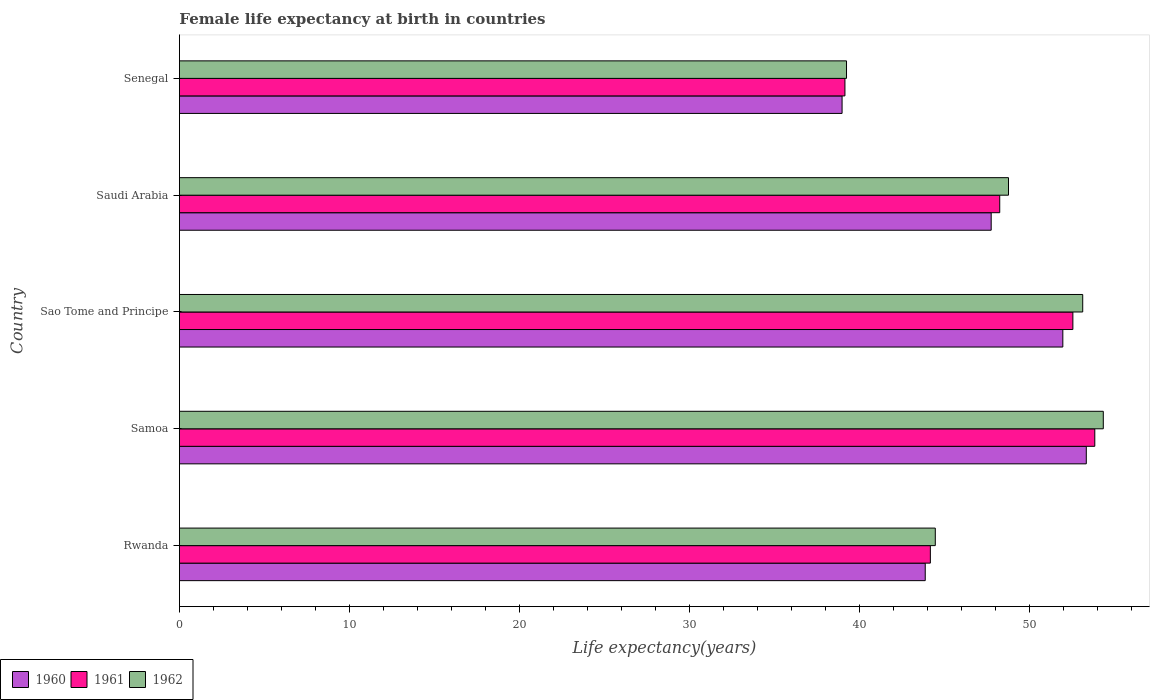How many different coloured bars are there?
Give a very brief answer. 3. Are the number of bars per tick equal to the number of legend labels?
Give a very brief answer. Yes. Are the number of bars on each tick of the Y-axis equal?
Provide a short and direct response. Yes. How many bars are there on the 1st tick from the top?
Provide a succinct answer. 3. How many bars are there on the 5th tick from the bottom?
Your answer should be compact. 3. What is the label of the 5th group of bars from the top?
Keep it short and to the point. Rwanda. What is the female life expectancy at birth in 1962 in Rwanda?
Make the answer very short. 44.47. Across all countries, what is the maximum female life expectancy at birth in 1960?
Your answer should be very brief. 53.35. Across all countries, what is the minimum female life expectancy at birth in 1960?
Your answer should be very brief. 38.98. In which country was the female life expectancy at birth in 1962 maximum?
Make the answer very short. Samoa. In which country was the female life expectancy at birth in 1961 minimum?
Offer a terse response. Senegal. What is the total female life expectancy at birth in 1962 in the graph?
Your answer should be very brief. 239.97. What is the difference between the female life expectancy at birth in 1962 in Samoa and that in Senegal?
Offer a terse response. 15.11. What is the difference between the female life expectancy at birth in 1962 in Senegal and the female life expectancy at birth in 1961 in Sao Tome and Principe?
Provide a short and direct response. -13.32. What is the average female life expectancy at birth in 1961 per country?
Keep it short and to the point. 47.6. What is the difference between the female life expectancy at birth in 1961 and female life expectancy at birth in 1962 in Rwanda?
Give a very brief answer. -0.29. In how many countries, is the female life expectancy at birth in 1961 greater than 52 years?
Ensure brevity in your answer.  2. What is the ratio of the female life expectancy at birth in 1961 in Rwanda to that in Samoa?
Give a very brief answer. 0.82. Is the female life expectancy at birth in 1961 in Saudi Arabia less than that in Senegal?
Make the answer very short. No. Is the difference between the female life expectancy at birth in 1961 in Rwanda and Senegal greater than the difference between the female life expectancy at birth in 1962 in Rwanda and Senegal?
Provide a short and direct response. No. What is the difference between the highest and the second highest female life expectancy at birth in 1962?
Give a very brief answer. 1.21. What is the difference between the highest and the lowest female life expectancy at birth in 1961?
Your answer should be compact. 14.7. In how many countries, is the female life expectancy at birth in 1960 greater than the average female life expectancy at birth in 1960 taken over all countries?
Give a very brief answer. 3. What does the 2nd bar from the bottom in Samoa represents?
Give a very brief answer. 1961. Is it the case that in every country, the sum of the female life expectancy at birth in 1962 and female life expectancy at birth in 1961 is greater than the female life expectancy at birth in 1960?
Your answer should be compact. Yes. How many bars are there?
Give a very brief answer. 15. How many countries are there in the graph?
Ensure brevity in your answer.  5. What is the difference between two consecutive major ticks on the X-axis?
Your answer should be compact. 10. Are the values on the major ticks of X-axis written in scientific E-notation?
Make the answer very short. No. Where does the legend appear in the graph?
Ensure brevity in your answer.  Bottom left. How many legend labels are there?
Your response must be concise. 3. How are the legend labels stacked?
Your response must be concise. Horizontal. What is the title of the graph?
Provide a short and direct response. Female life expectancy at birth in countries. What is the label or title of the X-axis?
Give a very brief answer. Life expectancy(years). What is the Life expectancy(years) in 1960 in Rwanda?
Give a very brief answer. 43.88. What is the Life expectancy(years) of 1961 in Rwanda?
Offer a very short reply. 44.18. What is the Life expectancy(years) in 1962 in Rwanda?
Ensure brevity in your answer.  44.47. What is the Life expectancy(years) in 1960 in Samoa?
Your answer should be compact. 53.35. What is the Life expectancy(years) of 1961 in Samoa?
Your response must be concise. 53.85. What is the Life expectancy(years) in 1962 in Samoa?
Your answer should be compact. 54.35. What is the Life expectancy(years) in 1960 in Sao Tome and Principe?
Offer a very short reply. 51.97. What is the Life expectancy(years) in 1961 in Sao Tome and Principe?
Provide a succinct answer. 52.56. What is the Life expectancy(years) of 1962 in Sao Tome and Principe?
Keep it short and to the point. 53.14. What is the Life expectancy(years) of 1960 in Saudi Arabia?
Make the answer very short. 47.76. What is the Life expectancy(years) in 1961 in Saudi Arabia?
Your response must be concise. 48.26. What is the Life expectancy(years) in 1962 in Saudi Arabia?
Offer a very short reply. 48.77. What is the Life expectancy(years) of 1960 in Senegal?
Provide a succinct answer. 38.98. What is the Life expectancy(years) in 1961 in Senegal?
Provide a short and direct response. 39.15. What is the Life expectancy(years) in 1962 in Senegal?
Offer a terse response. 39.24. Across all countries, what is the maximum Life expectancy(years) of 1960?
Give a very brief answer. 53.35. Across all countries, what is the maximum Life expectancy(years) in 1961?
Provide a short and direct response. 53.85. Across all countries, what is the maximum Life expectancy(years) of 1962?
Provide a short and direct response. 54.35. Across all countries, what is the minimum Life expectancy(years) of 1960?
Ensure brevity in your answer.  38.98. Across all countries, what is the minimum Life expectancy(years) in 1961?
Ensure brevity in your answer.  39.15. Across all countries, what is the minimum Life expectancy(years) in 1962?
Your response must be concise. 39.24. What is the total Life expectancy(years) of 1960 in the graph?
Give a very brief answer. 235.93. What is the total Life expectancy(years) of 1961 in the graph?
Your response must be concise. 238. What is the total Life expectancy(years) in 1962 in the graph?
Provide a short and direct response. 239.97. What is the difference between the Life expectancy(years) in 1960 in Rwanda and that in Samoa?
Provide a short and direct response. -9.47. What is the difference between the Life expectancy(years) of 1961 in Rwanda and that in Samoa?
Your answer should be compact. -9.67. What is the difference between the Life expectancy(years) of 1962 in Rwanda and that in Samoa?
Provide a short and direct response. -9.88. What is the difference between the Life expectancy(years) in 1960 in Rwanda and that in Sao Tome and Principe?
Offer a very short reply. -8.09. What is the difference between the Life expectancy(years) of 1961 in Rwanda and that in Sao Tome and Principe?
Your response must be concise. -8.38. What is the difference between the Life expectancy(years) in 1962 in Rwanda and that in Sao Tome and Principe?
Your response must be concise. -8.67. What is the difference between the Life expectancy(years) in 1960 in Rwanda and that in Saudi Arabia?
Provide a short and direct response. -3.88. What is the difference between the Life expectancy(years) in 1961 in Rwanda and that in Saudi Arabia?
Offer a terse response. -4.08. What is the difference between the Life expectancy(years) of 1962 in Rwanda and that in Saudi Arabia?
Keep it short and to the point. -4.31. What is the difference between the Life expectancy(years) of 1960 in Rwanda and that in Senegal?
Ensure brevity in your answer.  4.89. What is the difference between the Life expectancy(years) in 1961 in Rwanda and that in Senegal?
Provide a short and direct response. 5.03. What is the difference between the Life expectancy(years) of 1962 in Rwanda and that in Senegal?
Make the answer very short. 5.22. What is the difference between the Life expectancy(years) in 1960 in Samoa and that in Sao Tome and Principe?
Provide a succinct answer. 1.38. What is the difference between the Life expectancy(years) in 1961 in Samoa and that in Sao Tome and Principe?
Ensure brevity in your answer.  1.29. What is the difference between the Life expectancy(years) in 1962 in Samoa and that in Sao Tome and Principe?
Your answer should be very brief. 1.21. What is the difference between the Life expectancy(years) in 1960 in Samoa and that in Saudi Arabia?
Keep it short and to the point. 5.59. What is the difference between the Life expectancy(years) of 1961 in Samoa and that in Saudi Arabia?
Offer a very short reply. 5.59. What is the difference between the Life expectancy(years) in 1962 in Samoa and that in Saudi Arabia?
Your response must be concise. 5.58. What is the difference between the Life expectancy(years) of 1960 in Samoa and that in Senegal?
Provide a succinct answer. 14.37. What is the difference between the Life expectancy(years) in 1961 in Samoa and that in Senegal?
Your answer should be very brief. 14.7. What is the difference between the Life expectancy(years) in 1962 in Samoa and that in Senegal?
Provide a short and direct response. 15.11. What is the difference between the Life expectancy(years) of 1960 in Sao Tome and Principe and that in Saudi Arabia?
Offer a very short reply. 4.21. What is the difference between the Life expectancy(years) in 1961 in Sao Tome and Principe and that in Saudi Arabia?
Your answer should be very brief. 4.3. What is the difference between the Life expectancy(years) in 1962 in Sao Tome and Principe and that in Saudi Arabia?
Make the answer very short. 4.37. What is the difference between the Life expectancy(years) in 1960 in Sao Tome and Principe and that in Senegal?
Offer a terse response. 12.99. What is the difference between the Life expectancy(years) in 1961 in Sao Tome and Principe and that in Senegal?
Give a very brief answer. 13.41. What is the difference between the Life expectancy(years) of 1962 in Sao Tome and Principe and that in Senegal?
Your response must be concise. 13.89. What is the difference between the Life expectancy(years) of 1960 in Saudi Arabia and that in Senegal?
Give a very brief answer. 8.77. What is the difference between the Life expectancy(years) of 1961 in Saudi Arabia and that in Senegal?
Provide a short and direct response. 9.11. What is the difference between the Life expectancy(years) in 1962 in Saudi Arabia and that in Senegal?
Your answer should be compact. 9.53. What is the difference between the Life expectancy(years) of 1960 in Rwanda and the Life expectancy(years) of 1961 in Samoa?
Your answer should be very brief. -9.97. What is the difference between the Life expectancy(years) of 1960 in Rwanda and the Life expectancy(years) of 1962 in Samoa?
Offer a terse response. -10.47. What is the difference between the Life expectancy(years) of 1961 in Rwanda and the Life expectancy(years) of 1962 in Samoa?
Offer a terse response. -10.17. What is the difference between the Life expectancy(years) of 1960 in Rwanda and the Life expectancy(years) of 1961 in Sao Tome and Principe?
Ensure brevity in your answer.  -8.69. What is the difference between the Life expectancy(years) in 1960 in Rwanda and the Life expectancy(years) in 1962 in Sao Tome and Principe?
Keep it short and to the point. -9.26. What is the difference between the Life expectancy(years) in 1961 in Rwanda and the Life expectancy(years) in 1962 in Sao Tome and Principe?
Your answer should be compact. -8.96. What is the difference between the Life expectancy(years) of 1960 in Rwanda and the Life expectancy(years) of 1961 in Saudi Arabia?
Provide a short and direct response. -4.38. What is the difference between the Life expectancy(years) in 1960 in Rwanda and the Life expectancy(years) in 1962 in Saudi Arabia?
Your answer should be very brief. -4.9. What is the difference between the Life expectancy(years) of 1961 in Rwanda and the Life expectancy(years) of 1962 in Saudi Arabia?
Provide a short and direct response. -4.6. What is the difference between the Life expectancy(years) in 1960 in Rwanda and the Life expectancy(years) in 1961 in Senegal?
Offer a very short reply. 4.72. What is the difference between the Life expectancy(years) in 1960 in Rwanda and the Life expectancy(years) in 1962 in Senegal?
Your answer should be very brief. 4.63. What is the difference between the Life expectancy(years) of 1961 in Rwanda and the Life expectancy(years) of 1962 in Senegal?
Offer a terse response. 4.93. What is the difference between the Life expectancy(years) of 1960 in Samoa and the Life expectancy(years) of 1961 in Sao Tome and Principe?
Provide a succinct answer. 0.79. What is the difference between the Life expectancy(years) of 1960 in Samoa and the Life expectancy(years) of 1962 in Sao Tome and Principe?
Your answer should be compact. 0.21. What is the difference between the Life expectancy(years) in 1961 in Samoa and the Life expectancy(years) in 1962 in Sao Tome and Principe?
Your response must be concise. 0.71. What is the difference between the Life expectancy(years) of 1960 in Samoa and the Life expectancy(years) of 1961 in Saudi Arabia?
Provide a short and direct response. 5.09. What is the difference between the Life expectancy(years) of 1960 in Samoa and the Life expectancy(years) of 1962 in Saudi Arabia?
Your response must be concise. 4.58. What is the difference between the Life expectancy(years) in 1961 in Samoa and the Life expectancy(years) in 1962 in Saudi Arabia?
Offer a very short reply. 5.08. What is the difference between the Life expectancy(years) in 1960 in Samoa and the Life expectancy(years) in 1961 in Senegal?
Provide a succinct answer. 14.2. What is the difference between the Life expectancy(years) of 1960 in Samoa and the Life expectancy(years) of 1962 in Senegal?
Offer a very short reply. 14.11. What is the difference between the Life expectancy(years) in 1961 in Samoa and the Life expectancy(years) in 1962 in Senegal?
Your answer should be very brief. 14.61. What is the difference between the Life expectancy(years) of 1960 in Sao Tome and Principe and the Life expectancy(years) of 1961 in Saudi Arabia?
Provide a succinct answer. 3.71. What is the difference between the Life expectancy(years) of 1960 in Sao Tome and Principe and the Life expectancy(years) of 1962 in Saudi Arabia?
Provide a short and direct response. 3.2. What is the difference between the Life expectancy(years) of 1961 in Sao Tome and Principe and the Life expectancy(years) of 1962 in Saudi Arabia?
Make the answer very short. 3.79. What is the difference between the Life expectancy(years) in 1960 in Sao Tome and Principe and the Life expectancy(years) in 1961 in Senegal?
Your answer should be compact. 12.82. What is the difference between the Life expectancy(years) in 1960 in Sao Tome and Principe and the Life expectancy(years) in 1962 in Senegal?
Make the answer very short. 12.72. What is the difference between the Life expectancy(years) in 1961 in Sao Tome and Principe and the Life expectancy(years) in 1962 in Senegal?
Keep it short and to the point. 13.32. What is the difference between the Life expectancy(years) in 1960 in Saudi Arabia and the Life expectancy(years) in 1961 in Senegal?
Your answer should be very brief. 8.6. What is the difference between the Life expectancy(years) in 1960 in Saudi Arabia and the Life expectancy(years) in 1962 in Senegal?
Make the answer very short. 8.51. What is the difference between the Life expectancy(years) of 1961 in Saudi Arabia and the Life expectancy(years) of 1962 in Senegal?
Provide a short and direct response. 9.01. What is the average Life expectancy(years) in 1960 per country?
Make the answer very short. 47.19. What is the average Life expectancy(years) in 1961 per country?
Offer a terse response. 47.6. What is the average Life expectancy(years) in 1962 per country?
Provide a succinct answer. 47.99. What is the difference between the Life expectancy(years) in 1960 and Life expectancy(years) in 1961 in Rwanda?
Your response must be concise. -0.3. What is the difference between the Life expectancy(years) of 1960 and Life expectancy(years) of 1962 in Rwanda?
Provide a short and direct response. -0.59. What is the difference between the Life expectancy(years) in 1961 and Life expectancy(years) in 1962 in Rwanda?
Provide a short and direct response. -0.29. What is the difference between the Life expectancy(years) of 1960 and Life expectancy(years) of 1961 in Samoa?
Your answer should be compact. -0.5. What is the difference between the Life expectancy(years) of 1961 and Life expectancy(years) of 1962 in Samoa?
Give a very brief answer. -0.5. What is the difference between the Life expectancy(years) in 1960 and Life expectancy(years) in 1961 in Sao Tome and Principe?
Your answer should be compact. -0.59. What is the difference between the Life expectancy(years) of 1960 and Life expectancy(years) of 1962 in Sao Tome and Principe?
Your answer should be very brief. -1.17. What is the difference between the Life expectancy(years) of 1961 and Life expectancy(years) of 1962 in Sao Tome and Principe?
Ensure brevity in your answer.  -0.58. What is the difference between the Life expectancy(years) in 1960 and Life expectancy(years) in 1961 in Saudi Arabia?
Offer a terse response. -0.5. What is the difference between the Life expectancy(years) in 1960 and Life expectancy(years) in 1962 in Saudi Arabia?
Offer a very short reply. -1.02. What is the difference between the Life expectancy(years) in 1961 and Life expectancy(years) in 1962 in Saudi Arabia?
Ensure brevity in your answer.  -0.52. What is the difference between the Life expectancy(years) of 1960 and Life expectancy(years) of 1961 in Senegal?
Offer a terse response. -0.17. What is the difference between the Life expectancy(years) in 1960 and Life expectancy(years) in 1962 in Senegal?
Your response must be concise. -0.26. What is the difference between the Life expectancy(years) of 1961 and Life expectancy(years) of 1962 in Senegal?
Offer a terse response. -0.09. What is the ratio of the Life expectancy(years) in 1960 in Rwanda to that in Samoa?
Your response must be concise. 0.82. What is the ratio of the Life expectancy(years) in 1961 in Rwanda to that in Samoa?
Keep it short and to the point. 0.82. What is the ratio of the Life expectancy(years) in 1962 in Rwanda to that in Samoa?
Your answer should be very brief. 0.82. What is the ratio of the Life expectancy(years) of 1960 in Rwanda to that in Sao Tome and Principe?
Your answer should be compact. 0.84. What is the ratio of the Life expectancy(years) of 1961 in Rwanda to that in Sao Tome and Principe?
Your answer should be compact. 0.84. What is the ratio of the Life expectancy(years) in 1962 in Rwanda to that in Sao Tome and Principe?
Provide a short and direct response. 0.84. What is the ratio of the Life expectancy(years) of 1960 in Rwanda to that in Saudi Arabia?
Provide a succinct answer. 0.92. What is the ratio of the Life expectancy(years) in 1961 in Rwanda to that in Saudi Arabia?
Keep it short and to the point. 0.92. What is the ratio of the Life expectancy(years) in 1962 in Rwanda to that in Saudi Arabia?
Provide a succinct answer. 0.91. What is the ratio of the Life expectancy(years) in 1960 in Rwanda to that in Senegal?
Give a very brief answer. 1.13. What is the ratio of the Life expectancy(years) in 1961 in Rwanda to that in Senegal?
Ensure brevity in your answer.  1.13. What is the ratio of the Life expectancy(years) of 1962 in Rwanda to that in Senegal?
Offer a terse response. 1.13. What is the ratio of the Life expectancy(years) of 1960 in Samoa to that in Sao Tome and Principe?
Keep it short and to the point. 1.03. What is the ratio of the Life expectancy(years) of 1961 in Samoa to that in Sao Tome and Principe?
Make the answer very short. 1.02. What is the ratio of the Life expectancy(years) of 1962 in Samoa to that in Sao Tome and Principe?
Offer a very short reply. 1.02. What is the ratio of the Life expectancy(years) of 1960 in Samoa to that in Saudi Arabia?
Keep it short and to the point. 1.12. What is the ratio of the Life expectancy(years) in 1961 in Samoa to that in Saudi Arabia?
Provide a short and direct response. 1.12. What is the ratio of the Life expectancy(years) in 1962 in Samoa to that in Saudi Arabia?
Make the answer very short. 1.11. What is the ratio of the Life expectancy(years) of 1960 in Samoa to that in Senegal?
Your answer should be compact. 1.37. What is the ratio of the Life expectancy(years) in 1961 in Samoa to that in Senegal?
Your answer should be compact. 1.38. What is the ratio of the Life expectancy(years) of 1962 in Samoa to that in Senegal?
Offer a terse response. 1.38. What is the ratio of the Life expectancy(years) in 1960 in Sao Tome and Principe to that in Saudi Arabia?
Make the answer very short. 1.09. What is the ratio of the Life expectancy(years) in 1961 in Sao Tome and Principe to that in Saudi Arabia?
Your answer should be very brief. 1.09. What is the ratio of the Life expectancy(years) in 1962 in Sao Tome and Principe to that in Saudi Arabia?
Offer a terse response. 1.09. What is the ratio of the Life expectancy(years) of 1960 in Sao Tome and Principe to that in Senegal?
Ensure brevity in your answer.  1.33. What is the ratio of the Life expectancy(years) in 1961 in Sao Tome and Principe to that in Senegal?
Give a very brief answer. 1.34. What is the ratio of the Life expectancy(years) of 1962 in Sao Tome and Principe to that in Senegal?
Offer a terse response. 1.35. What is the ratio of the Life expectancy(years) in 1960 in Saudi Arabia to that in Senegal?
Provide a short and direct response. 1.23. What is the ratio of the Life expectancy(years) in 1961 in Saudi Arabia to that in Senegal?
Give a very brief answer. 1.23. What is the ratio of the Life expectancy(years) of 1962 in Saudi Arabia to that in Senegal?
Give a very brief answer. 1.24. What is the difference between the highest and the second highest Life expectancy(years) of 1960?
Provide a short and direct response. 1.38. What is the difference between the highest and the second highest Life expectancy(years) in 1961?
Offer a terse response. 1.29. What is the difference between the highest and the second highest Life expectancy(years) in 1962?
Keep it short and to the point. 1.21. What is the difference between the highest and the lowest Life expectancy(years) in 1960?
Offer a very short reply. 14.37. What is the difference between the highest and the lowest Life expectancy(years) in 1961?
Give a very brief answer. 14.7. What is the difference between the highest and the lowest Life expectancy(years) of 1962?
Provide a succinct answer. 15.11. 